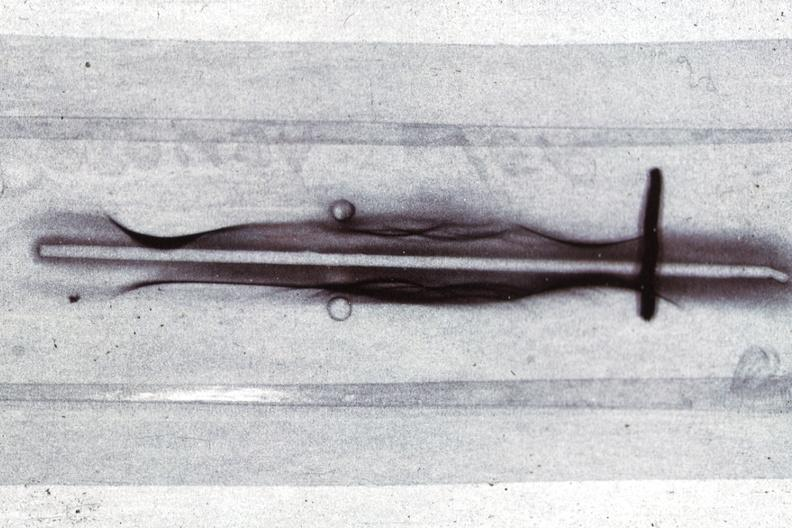what is present?
Answer the question using a single word or phrase. Blood 